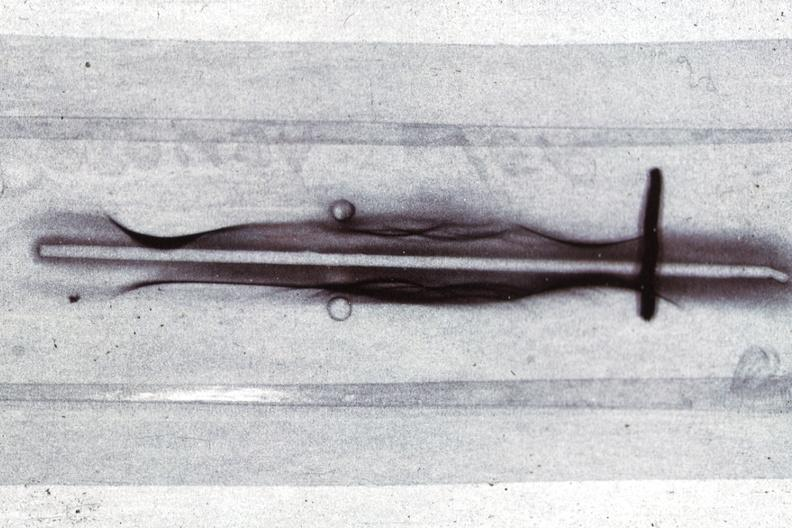what is present?
Answer the question using a single word or phrase. Blood 